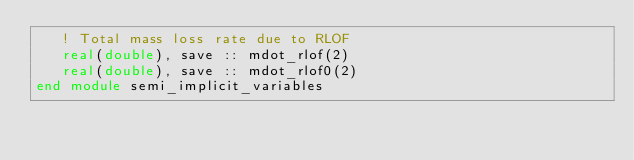<code> <loc_0><loc_0><loc_500><loc_500><_FORTRAN_>   ! Total mass loss rate due to RLOF
   real(double), save :: mdot_rlof(2)
   real(double), save :: mdot_rlof0(2)
end module semi_implicit_variables

</code> 